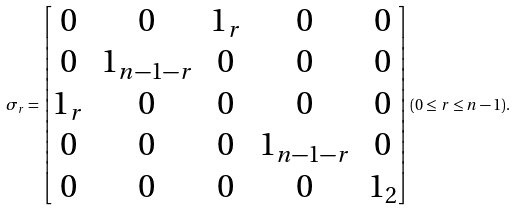<formula> <loc_0><loc_0><loc_500><loc_500>\sigma _ { r } = \begin{bmatrix} 0 & 0 & 1 _ { r } & 0 & 0 \\ 0 & 1 _ { n - 1 - r } & 0 & 0 & 0 \\ 1 _ { r } & 0 & 0 & 0 & 0 \\ 0 & 0 & 0 & 1 _ { n - 1 - r } & 0 \\ 0 & 0 & 0 & 0 & 1 _ { 2 } \\ \end{bmatrix} ( 0 \leq r \leq n - 1 ) .</formula> 